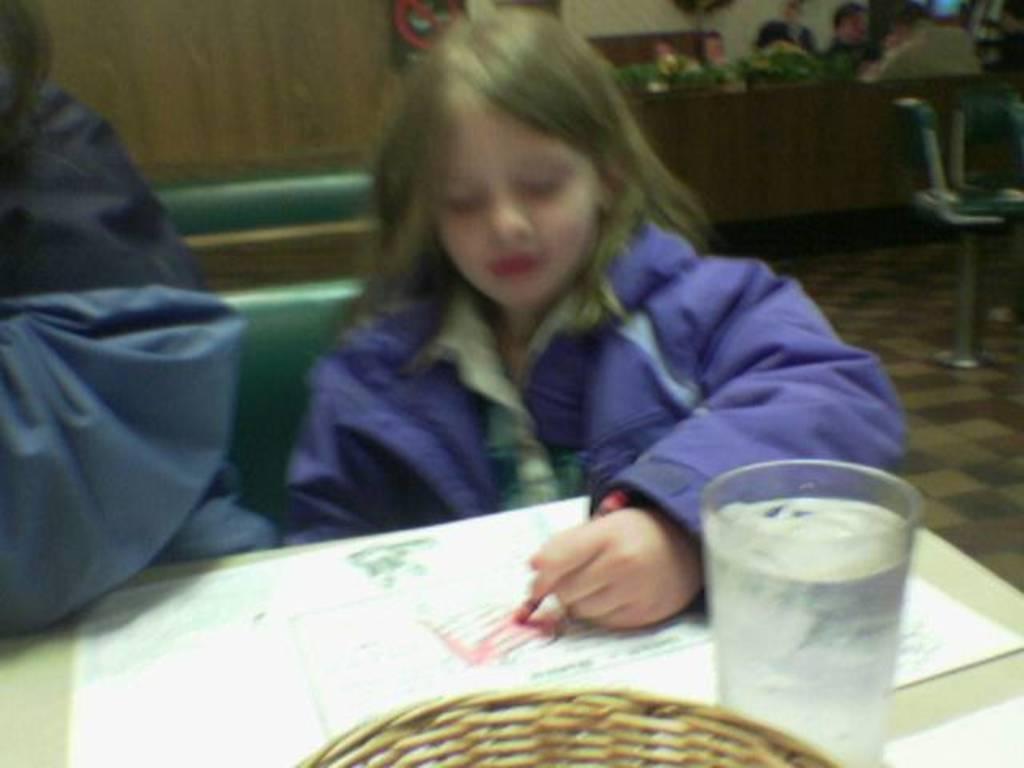Can you describe this image briefly? A girl is drawing and on the right everyone are sitting on the chairs. 